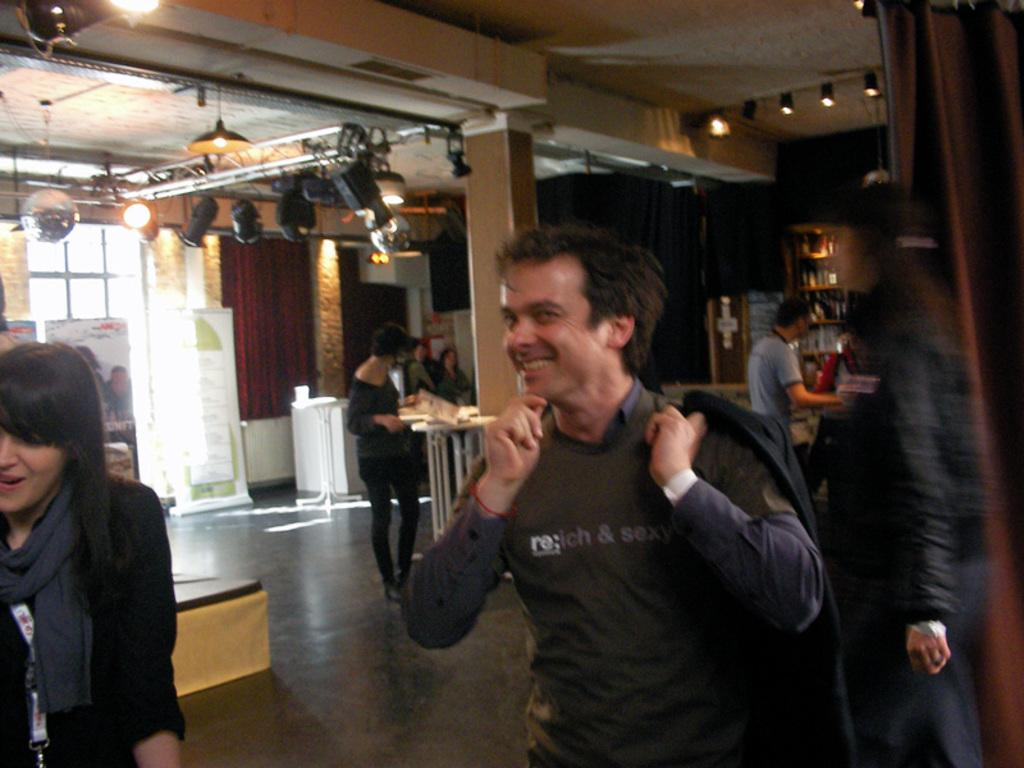How many groups of persons can be seen in the image? There are groups of persons in the image. What are the persons doing in the image? The persons are doing different activities in the image. Where are these activities taking place? The activities are taking place inside a hall. What can be seen in the top of the image? There are lights visible in the top of the image. What type of meal is being served in the image? There is no meal being served in the image; it features groups of persons doing different activities inside a hall. What message of peace is being conveyed in the image? There is no specific message of peace conveyed in the image; it simply shows groups of persons engaged in various activities. 